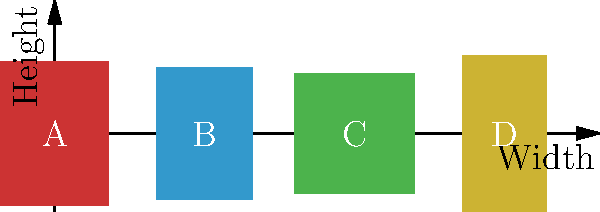Based on the book cover layouts shown above, which design is most likely to appeal to a broad international market for an Icelandic author's translated work? Consider factors such as aspect ratio, cultural neutrality, and visual impact. To determine the optimal book cover design for international markets, we need to consider several factors:

1. Aspect ratio: International markets often prefer standard sizes that are easily displayable and shippable.
2. Cultural neutrality: Designs that are too specific to one culture may not translate well to others.
3. Visual impact: The cover should be eye-catching and easily recognizable.

Let's analyze each design:

A. Red cover (1.8:2.4 ratio):
   - Tall and narrow, which may stand out but could be impractical for some markets.
   - Bold color choice, but may have cultural implications in some countries.

B. Blue cover (1.6:2.2 ratio):
   - More standard aspect ratio, closer to common book sizes.
   - Blue is often considered a neutral, calming color with broad appeal.

C. Green cover (2:2 ratio):
   - Square format, which is uncommon and may not fit well with standard shelving.
   - Green can symbolize nature, which might be relevant to Icelandic themes.

D. Yellow cover (1.4:2.6 ratio):
   - Very tall and narrow, which could be impractical for many markets.
   - Yellow is attention-grabbing but may have varying connotations across cultures.

Considering these factors, design B appears to be the most suitable for international markets:
- Its aspect ratio is closest to standard book sizes, making it practical for various markets.
- The blue color is generally well-received across cultures and has a broad appeal.
- The dimensions allow for easy shelving and shipping internationally.
- It provides a neutral backdrop that can be adaptable to various genres and themes.
Answer: Design B (blue cover with 1.6:2.2 ratio) 